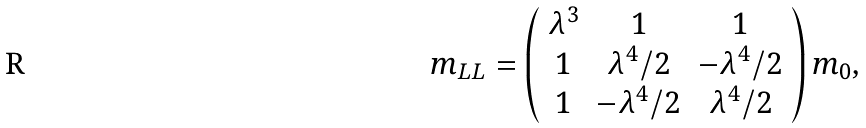Convert formula to latex. <formula><loc_0><loc_0><loc_500><loc_500>m _ { L L } = \left ( \begin{array} { c c c } \lambda ^ { 3 } & 1 & 1 \\ 1 & \lambda ^ { 4 } / 2 & - \lambda ^ { 4 } / 2 \\ 1 & - \lambda ^ { 4 } / 2 & \lambda ^ { 4 } / 2 \end{array} \right ) m _ { 0 } ,</formula> 